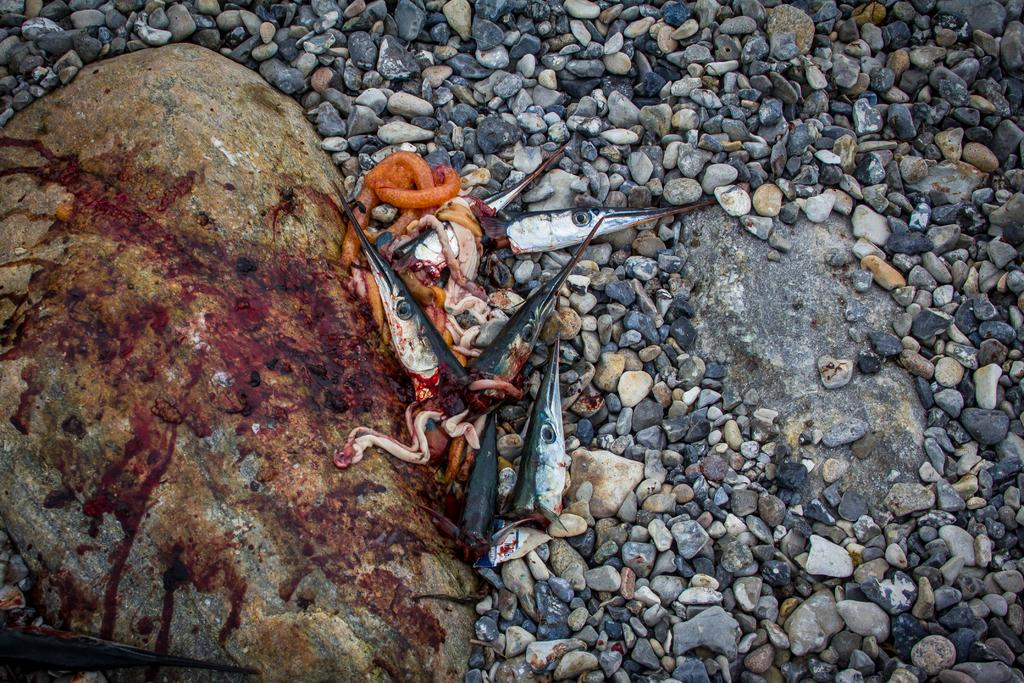What type of waste is visible in the image? There are waste parts of fish in the image. What is the blood on in the image? The blood is on a rock in the image. What type of natural objects can be seen in the image? There are stones in the image. What type of plantation can be seen in the image? There is no plantation present in the image. 